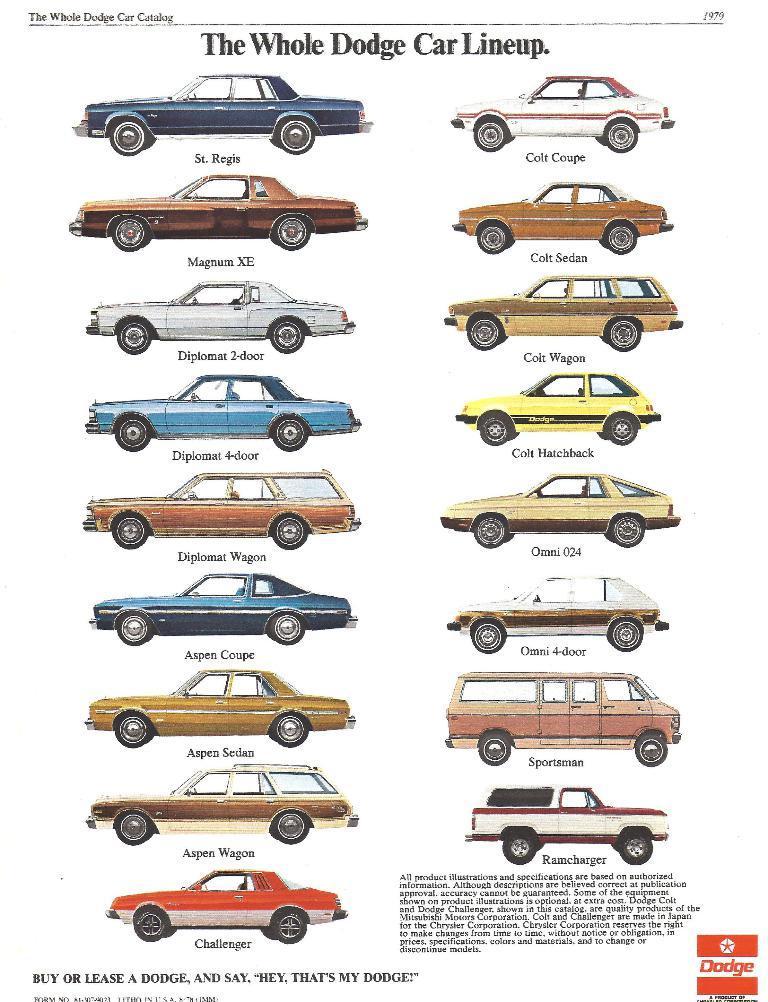How would you summarize this image in a sentence or two? In this image we can see a group of cars and some text on it. 